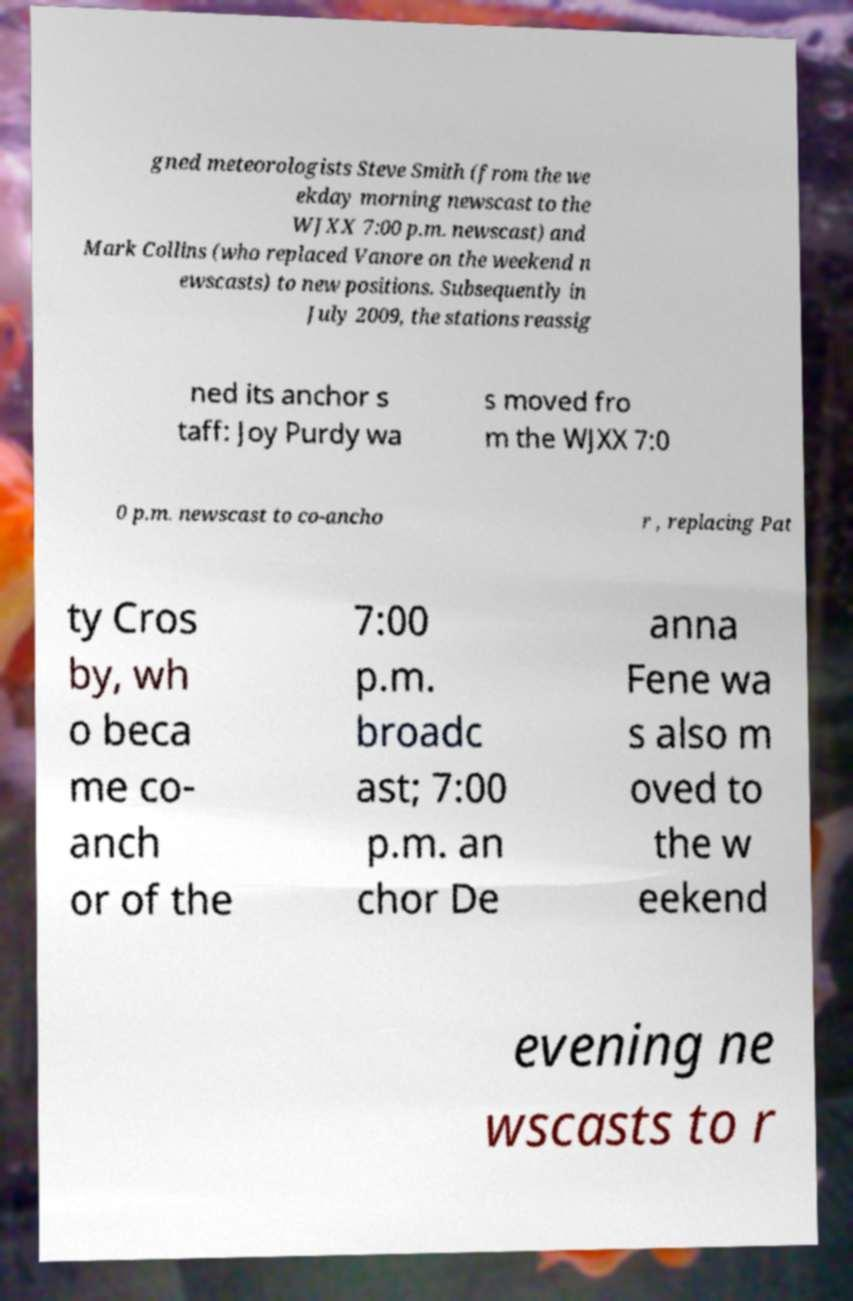There's text embedded in this image that I need extracted. Can you transcribe it verbatim? gned meteorologists Steve Smith (from the we ekday morning newscast to the WJXX 7:00 p.m. newscast) and Mark Collins (who replaced Vanore on the weekend n ewscasts) to new positions. Subsequently in July 2009, the stations reassig ned its anchor s taff: Joy Purdy wa s moved fro m the WJXX 7:0 0 p.m. newscast to co-ancho r , replacing Pat ty Cros by, wh o beca me co- anch or of the 7:00 p.m. broadc ast; 7:00 p.m. an chor De anna Fene wa s also m oved to the w eekend evening ne wscasts to r 